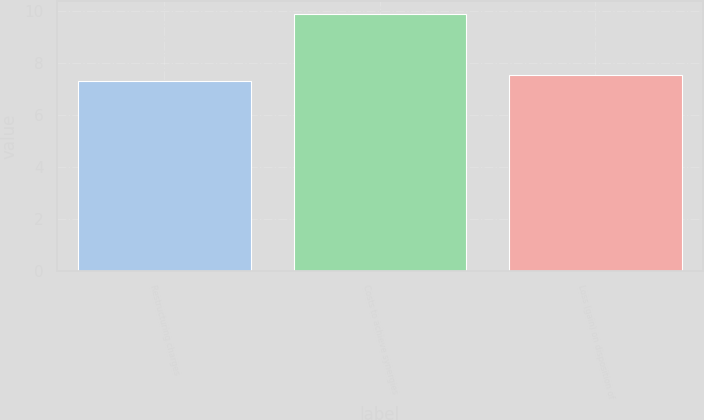<chart> <loc_0><loc_0><loc_500><loc_500><bar_chart><fcel>Restructuring charges<fcel>Costs to achieve synergies<fcel>Loss (gain) on disposition of<nl><fcel>7.3<fcel>9.9<fcel>7.56<nl></chart> 